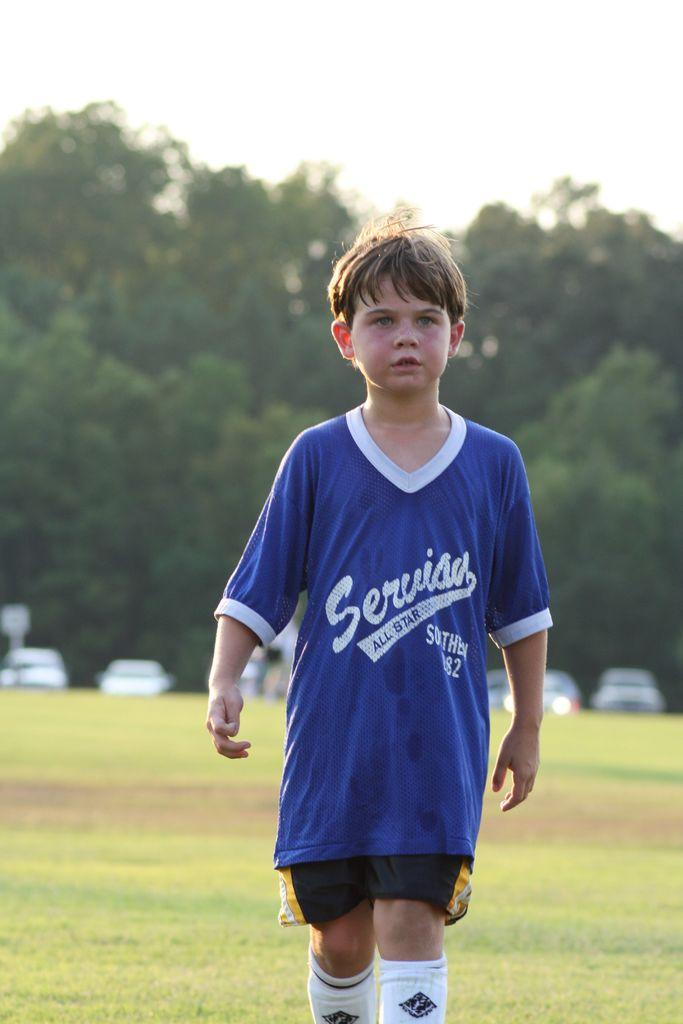<image>
Render a clear and concise summary of the photo. Servias stands out in the middle of the field alone. 